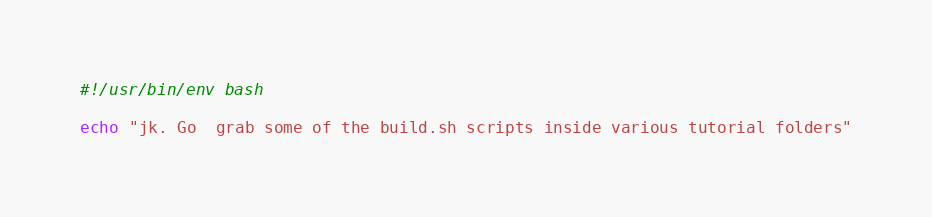<code> <loc_0><loc_0><loc_500><loc_500><_Bash_>#!/usr/bin/env bash

echo "jk. Go  grab some of the build.sh scripts inside various tutorial folders"
</code> 